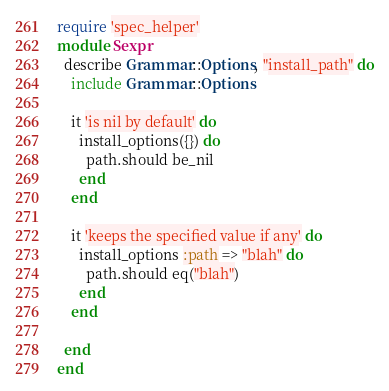Convert code to text. <code><loc_0><loc_0><loc_500><loc_500><_Ruby_>require 'spec_helper'
module Sexpr
  describe Grammar::Options, "install_path" do
    include Grammar::Options

    it 'is nil by default' do
      install_options({}) do
        path.should be_nil
      end
    end

    it 'keeps the specified value if any' do
      install_options :path => "blah" do
        path.should eq("blah")
      end
    end

  end
end</code> 